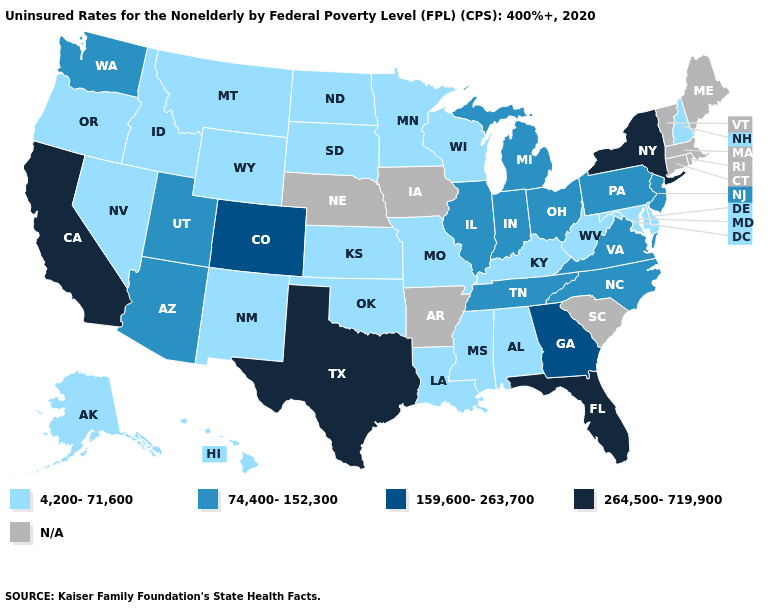What is the value of Alaska?
Keep it brief. 4,200-71,600. Name the states that have a value in the range 264,500-719,900?
Answer briefly. California, Florida, New York, Texas. Does South Dakota have the highest value in the MidWest?
Concise answer only. No. Among the states that border Nevada , which have the highest value?
Concise answer only. California. Does the map have missing data?
Write a very short answer. Yes. Does New Jersey have the highest value in the USA?
Answer briefly. No. Name the states that have a value in the range 74,400-152,300?
Be succinct. Arizona, Illinois, Indiana, Michigan, New Jersey, North Carolina, Ohio, Pennsylvania, Tennessee, Utah, Virginia, Washington. What is the value of Mississippi?
Be succinct. 4,200-71,600. Name the states that have a value in the range 74,400-152,300?
Short answer required. Arizona, Illinois, Indiana, Michigan, New Jersey, North Carolina, Ohio, Pennsylvania, Tennessee, Utah, Virginia, Washington. Name the states that have a value in the range 159,600-263,700?
Concise answer only. Colorado, Georgia. Which states have the lowest value in the USA?
Write a very short answer. Alabama, Alaska, Delaware, Hawaii, Idaho, Kansas, Kentucky, Louisiana, Maryland, Minnesota, Mississippi, Missouri, Montana, Nevada, New Hampshire, New Mexico, North Dakota, Oklahoma, Oregon, South Dakota, West Virginia, Wisconsin, Wyoming. Does the map have missing data?
Answer briefly. Yes. Does New Hampshire have the highest value in the Northeast?
Concise answer only. No. 